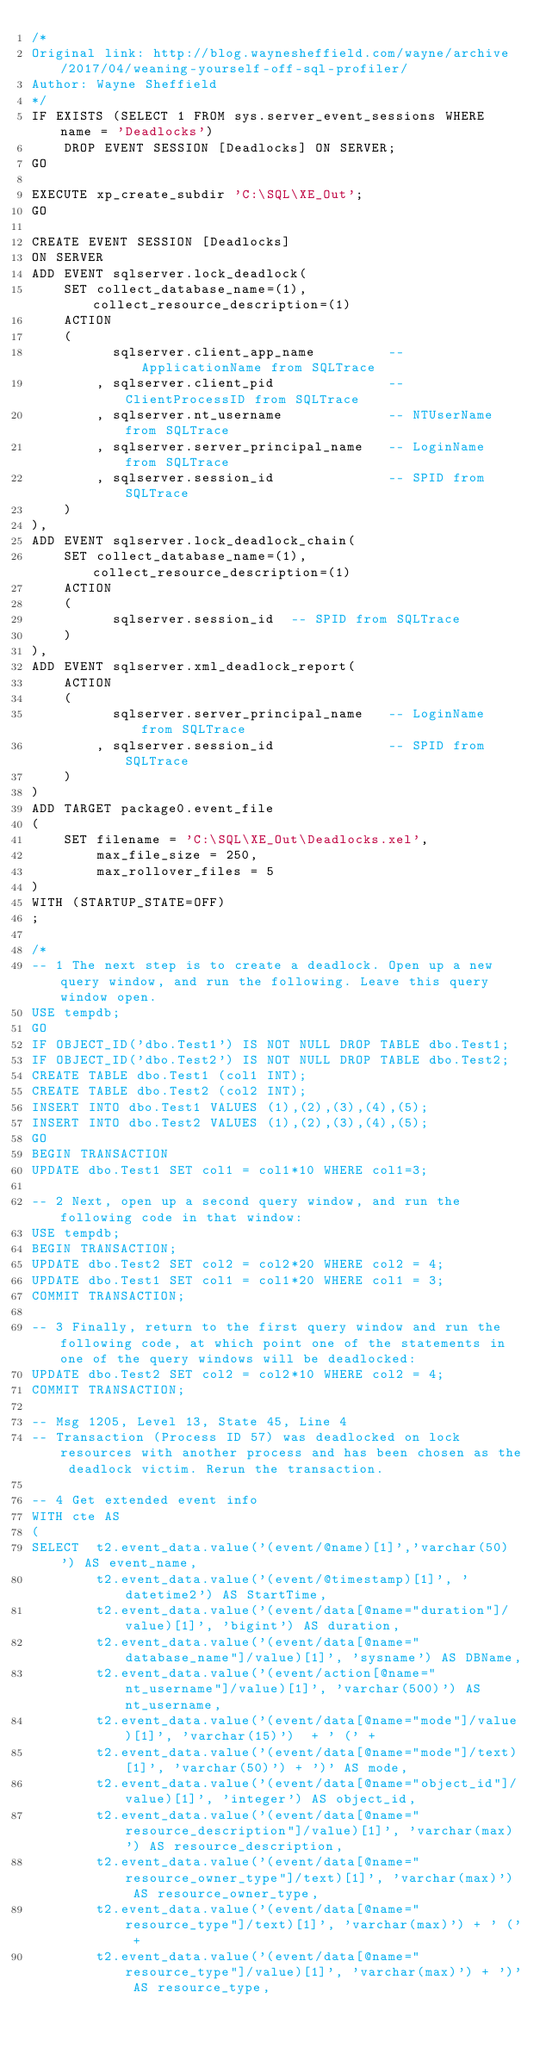<code> <loc_0><loc_0><loc_500><loc_500><_SQL_>/*
Original link: http://blog.waynesheffield.com/wayne/archive/2017/04/weaning-yourself-off-sql-profiler/
Author: Wayne Sheffield
*/
IF EXISTS (SELECT 1 FROM sys.server_event_sessions WHERE name = 'Deadlocks')
    DROP EVENT SESSION [Deadlocks] ON SERVER;
GO

EXECUTE xp_create_subdir 'C:\SQL\XE_Out';
GO

CREATE EVENT SESSION [Deadlocks]
ON SERVER
ADD EVENT sqlserver.lock_deadlock(
    SET collect_database_name=(1),collect_resource_description=(1)
    ACTION 
    (
          sqlserver.client_app_name         -- ApplicationName from SQLTrace
        , sqlserver.client_pid              -- ClientProcessID from SQLTrace
        , sqlserver.nt_username             -- NTUserName from SQLTrace
        , sqlserver.server_principal_name   -- LoginName from SQLTrace
        , sqlserver.session_id              -- SPID from SQLTrace
    )
),
ADD EVENT sqlserver.lock_deadlock_chain(
    SET collect_database_name=(1),collect_resource_description=(1)
    ACTION 
    (
          sqlserver.session_id  -- SPID from SQLTrace
    )
),
ADD EVENT sqlserver.xml_deadlock_report(
    ACTION 
    (
          sqlserver.server_principal_name   -- LoginName from SQLTrace
        , sqlserver.session_id              -- SPID from SQLTrace
    )
)
ADD TARGET package0.event_file
(
    SET filename = 'C:\SQL\XE_Out\Deadlocks.xel',
        max_file_size = 250,
        max_rollover_files = 5
)
WITH (STARTUP_STATE=OFF)
;

/*
-- 1 The next step is to create a deadlock. Open up a new query window, and run the following. Leave this query window open.
USE tempdb;
GO
IF OBJECT_ID('dbo.Test1') IS NOT NULL DROP TABLE dbo.Test1;
IF OBJECT_ID('dbo.Test2') IS NOT NULL DROP TABLE dbo.Test2;
CREATE TABLE dbo.Test1 (col1 INT);
CREATE TABLE dbo.Test2 (col2 INT);
INSERT INTO dbo.Test1 VALUES (1),(2),(3),(4),(5);
INSERT INTO dbo.Test2 VALUES (1),(2),(3),(4),(5);
GO
BEGIN TRANSACTION
UPDATE dbo.Test1 SET col1 = col1*10 WHERE col1=3;

-- 2 Next, open up a second query window, and run the following code in that window:
USE tempdb;
BEGIN TRANSACTION;
UPDATE dbo.Test2 SET col2 = col2*20 WHERE col2 = 4;
UPDATE dbo.Test1 SET col1 = col1*20 WHERE col1 = 3;
COMMIT TRANSACTION;

-- 3 Finally, return to the first query window and run the following code, at which point one of the statements in one of the query windows will be deadlocked:
UPDATE dbo.Test2 SET col2 = col2*10 WHERE col2 = 4;
COMMIT TRANSACTION;

-- Msg 1205, Level 13, State 45, Line 4
-- Transaction (Process ID 57) was deadlocked on lock resources with another process and has been chosen as the deadlock victim. Rerun the transaction.

-- 4 Get extended event info
WITH cte AS
(
SELECT  t2.event_data.value('(event/@name)[1]','varchar(50)') AS event_name,
        t2.event_data.value('(event/@timestamp)[1]', 'datetime2') AS StartTime,
        t2.event_data.value('(event/data[@name="duration"]/value)[1]', 'bigint') AS duration,
        t2.event_data.value('(event/data[@name="database_name"]/value)[1]', 'sysname') AS DBName,
        t2.event_data.value('(event/action[@name="nt_username"]/value)[1]', 'varchar(500)') AS nt_username,
        t2.event_data.value('(event/data[@name="mode"]/value)[1]', 'varchar(15)')  + ' (' + 
        t2.event_data.value('(event/data[@name="mode"]/text)[1]', 'varchar(50)') + ')' AS mode,
        t2.event_data.value('(event/data[@name="object_id"]/value)[1]', 'integer') AS object_id,
        t2.event_data.value('(event/data[@name="resource_description"]/value)[1]', 'varchar(max)') AS resource_description,
        t2.event_data.value('(event/data[@name="resource_owner_type"]/text)[1]', 'varchar(max)')  AS resource_owner_type,
        t2.event_data.value('(event/data[@name="resource_type"]/text)[1]', 'varchar(max)') + ' (' +
        t2.event_data.value('(event/data[@name="resource_type"]/value)[1]', 'varchar(max)') + ')' AS resource_type,</code> 